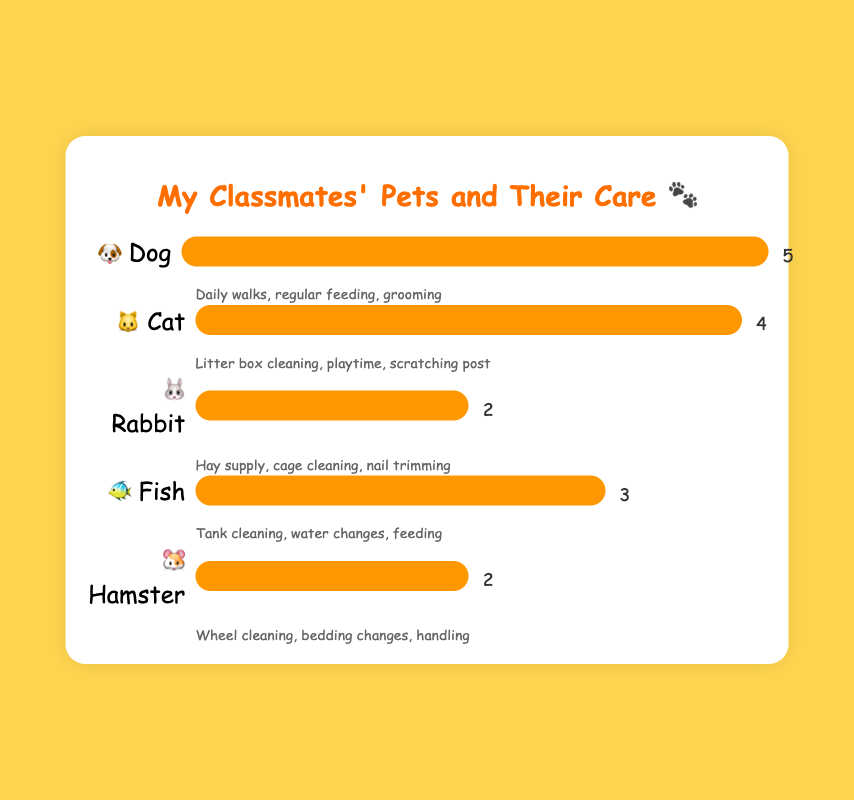What type of pet is owned by most classmates? The pet with the highest count is the one that most classmates have. The chart shows that dogs have a count of 5, which is the highest among the listed pets.
Answer: Dog Which pet requires a tank for living? By looking at the care requirements, the pet that needs tank cleaning and water changes is identified as the pet that requires a tank for living. According to the chart, fish have these care requirements.
Answer: Fish How many classmates own either a rabbit or a hamster? Summing up the counts of classmates who own rabbits and hamsters gives the answer. The chart shows 2 classmates own rabbits and 2 own hamsters. Therefore, 2 + 2 = 4.
Answer: 4 Which pets have an equal number of owners? Pets that have the same counts are identified as having an equal number of owners. The chart shows rabbits and hamsters both have counts of 2.
Answer: Rabbit and Hamster How many more classmates own dogs than cats? The number of dog owners is compared to the number of cat owners. According to the chart, there are 5 dog owners and 4 cat owners. So the difference is 5 - 4 = 1.
Answer: 1 What are the care requirements for cats? The care requirements listed next to the cat type are noted. According to the chart, cats need litter box cleaning, playtime, and a scratching post.
Answer: Litter box cleaning, playtime, scratching post Which pet needs daily walks as part of its care requirements? Looking at the care requirements for each pet, the one that mentions daily walks is identified. The chart indicates that dogs need daily walks.
Answer: Dog How many pets in total are owned by the classmates? Summing the counts of all the pets gives the total number of pets owned. The counts given are 5 for dogs, 4 for cats, 2 for rabbits, 3 for fish, and 2 for hamsters. So, 5 + 4 + 2 + 3 + 2 = 16.
Answer: 16 Which pet requires hay supply and nail trimming as part of its care? By reading the care requirements for each pet, the one that mentions hay supply and nail trimming is identified. The chart shows that rabbits need these care requirements.
Answer: Rabbit 